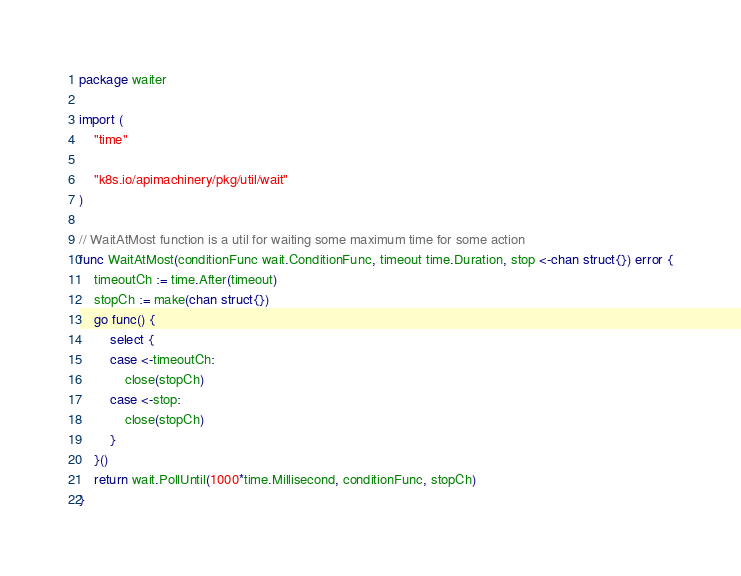<code> <loc_0><loc_0><loc_500><loc_500><_Go_>package waiter

import (
	"time"

	"k8s.io/apimachinery/pkg/util/wait"
)

// WaitAtMost function is a util for waiting some maximum time for some action
func WaitAtMost(conditionFunc wait.ConditionFunc, timeout time.Duration, stop <-chan struct{}) error {
	timeoutCh := time.After(timeout)
	stopCh := make(chan struct{})
	go func() {
		select {
		case <-timeoutCh:
			close(stopCh)
		case <-stop:
			close(stopCh)
		}
	}()
	return wait.PollUntil(1000*time.Millisecond, conditionFunc, stopCh)
}
</code> 